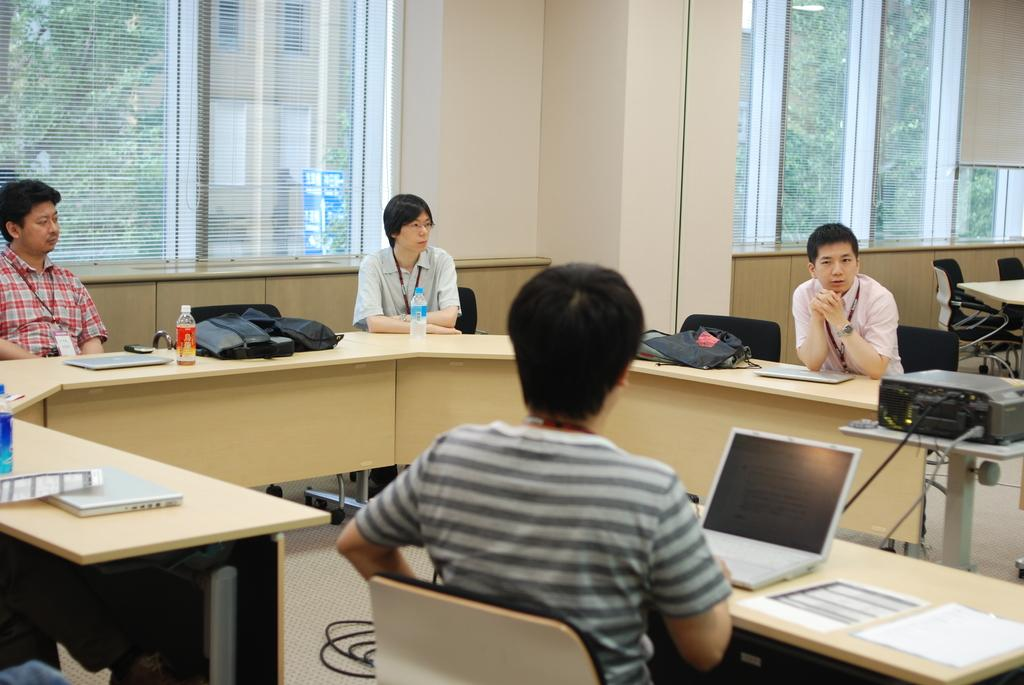What are the persons in the image doing? The persons in the image are sitting on chairs. What objects can be seen on the tables in the image? There is a bag, a bottle, and a laptop on the tables in the image. What is visible in the background of the image? There is a wall and a window in the background of the image. What part of the room is visible in the image? The floor is visible in the image. What type of ray is emitted from the laptop in the image? There is no ray emitted from the laptop in the image; it is a closed laptop on the table. 